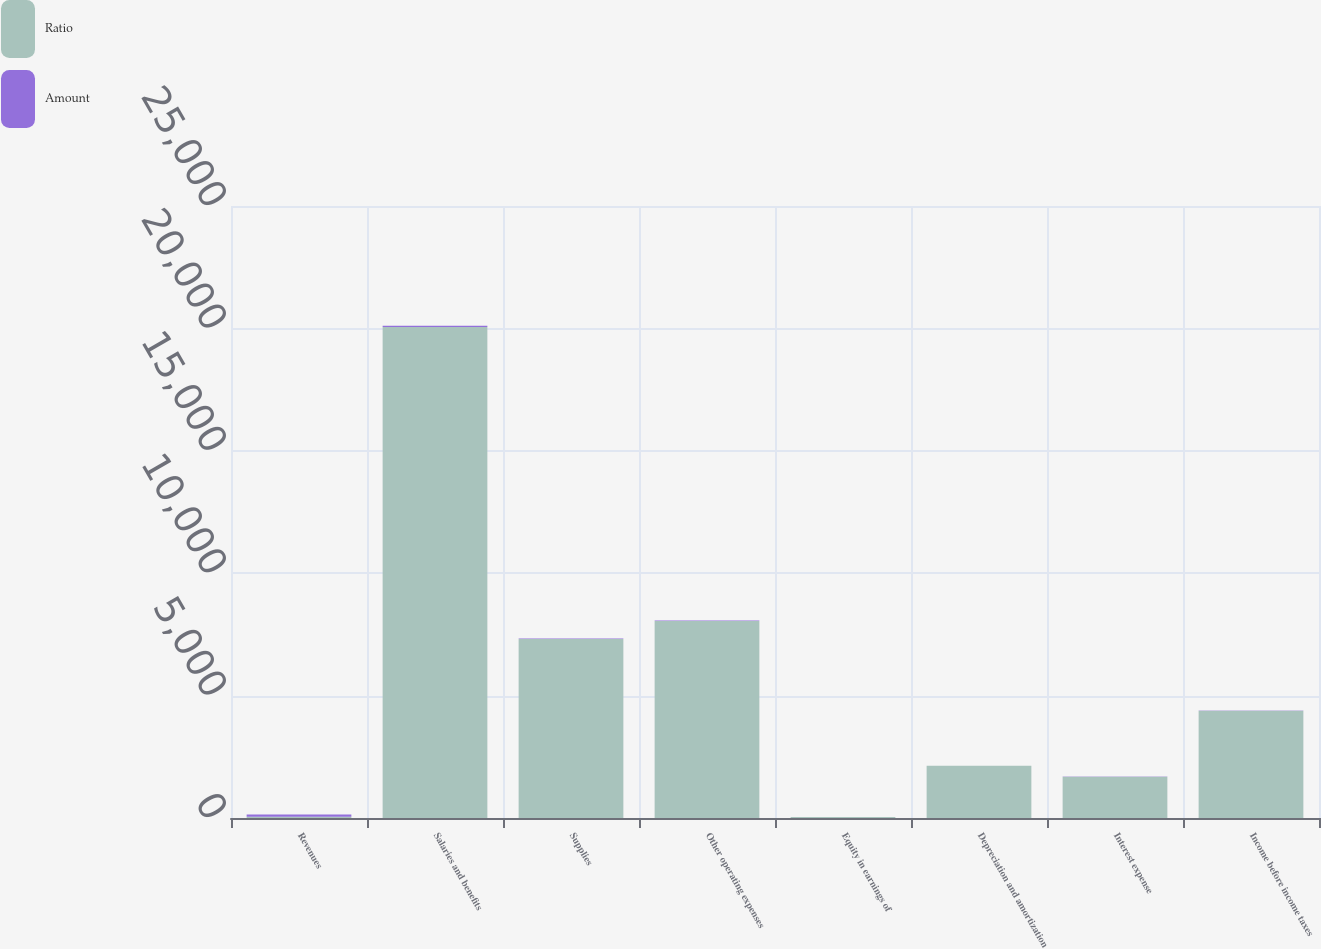Convert chart. <chart><loc_0><loc_0><loc_500><loc_500><stacked_bar_chart><ecel><fcel>Revenues<fcel>Salaries and benefits<fcel>Supplies<fcel>Other operating expenses<fcel>Equity in earnings of<fcel>Depreciation and amortization<fcel>Interest expense<fcel>Income before income taxes<nl><fcel>Ratio<fcel>46<fcel>20059<fcel>7316<fcel>8051<fcel>45<fcel>2131<fcel>1690<fcel>4381<nl><fcel>Amount<fcel>100<fcel>46<fcel>16.8<fcel>18.4<fcel>0.1<fcel>4.9<fcel>3.9<fcel>10<nl></chart> 